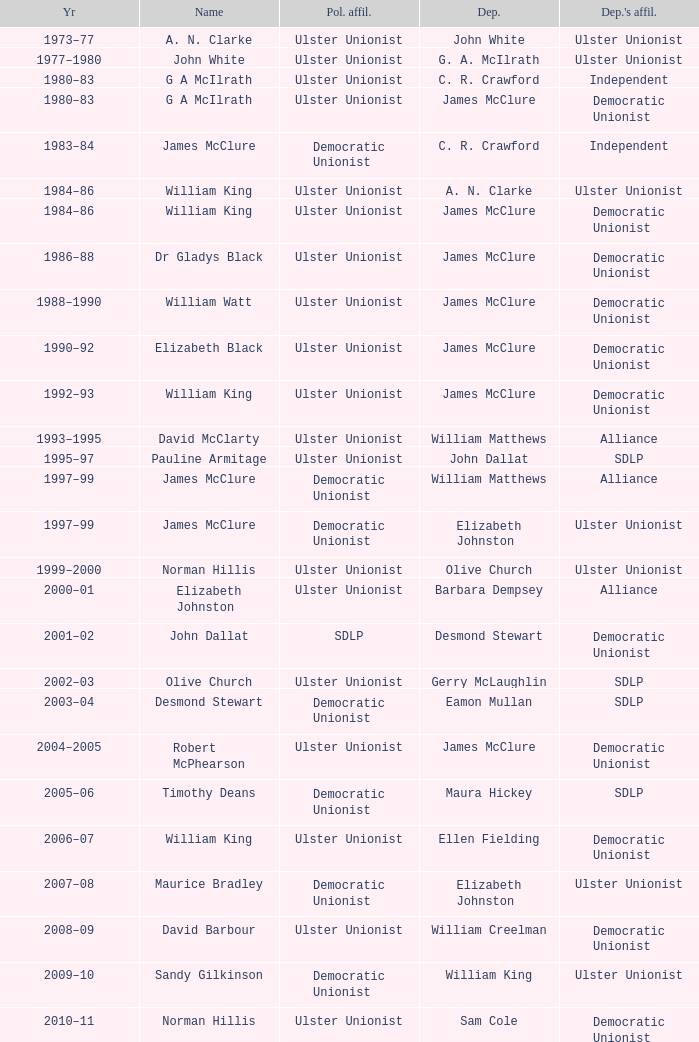What is the Name for 1997–99? James McClure, James McClure. 